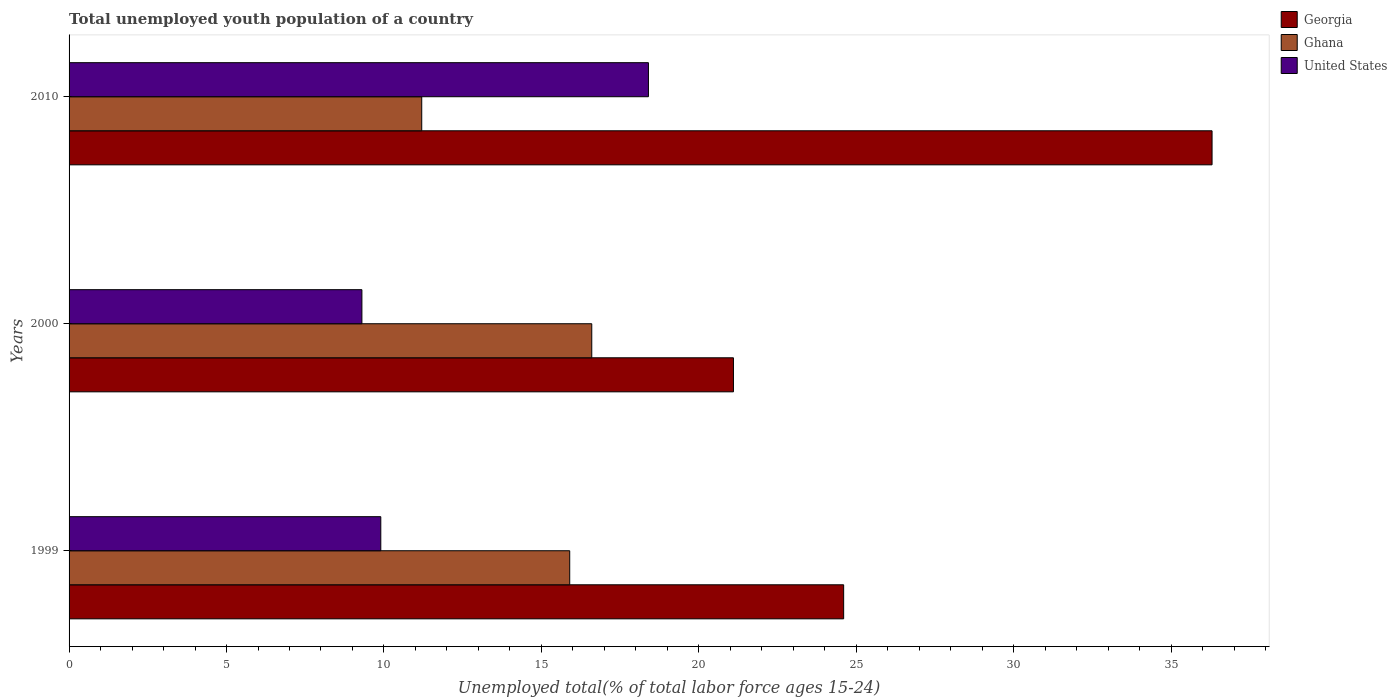How many different coloured bars are there?
Offer a terse response. 3. How many groups of bars are there?
Your answer should be compact. 3. Are the number of bars per tick equal to the number of legend labels?
Offer a terse response. Yes. Are the number of bars on each tick of the Y-axis equal?
Your response must be concise. Yes. How many bars are there on the 1st tick from the top?
Provide a succinct answer. 3. What is the label of the 1st group of bars from the top?
Your answer should be very brief. 2010. What is the percentage of total unemployed youth population of a country in Ghana in 1999?
Ensure brevity in your answer.  15.9. Across all years, what is the maximum percentage of total unemployed youth population of a country in Georgia?
Your response must be concise. 36.3. Across all years, what is the minimum percentage of total unemployed youth population of a country in Ghana?
Provide a succinct answer. 11.2. In which year was the percentage of total unemployed youth population of a country in Georgia maximum?
Offer a terse response. 2010. What is the total percentage of total unemployed youth population of a country in Georgia in the graph?
Provide a short and direct response. 82. What is the difference between the percentage of total unemployed youth population of a country in United States in 1999 and that in 2000?
Your response must be concise. 0.6. What is the difference between the percentage of total unemployed youth population of a country in Ghana in 2010 and the percentage of total unemployed youth population of a country in Georgia in 2000?
Your response must be concise. -9.9. What is the average percentage of total unemployed youth population of a country in Georgia per year?
Provide a short and direct response. 27.33. In the year 2010, what is the difference between the percentage of total unemployed youth population of a country in United States and percentage of total unemployed youth population of a country in Georgia?
Your answer should be very brief. -17.9. In how many years, is the percentage of total unemployed youth population of a country in United States greater than 22 %?
Your answer should be compact. 0. What is the ratio of the percentage of total unemployed youth population of a country in Ghana in 1999 to that in 2000?
Give a very brief answer. 0.96. Is the percentage of total unemployed youth population of a country in Ghana in 2000 less than that in 2010?
Your answer should be very brief. No. What is the difference between the highest and the second highest percentage of total unemployed youth population of a country in United States?
Provide a succinct answer. 8.5. What is the difference between the highest and the lowest percentage of total unemployed youth population of a country in Georgia?
Make the answer very short. 15.2. In how many years, is the percentage of total unemployed youth population of a country in Georgia greater than the average percentage of total unemployed youth population of a country in Georgia taken over all years?
Provide a short and direct response. 1. Is the sum of the percentage of total unemployed youth population of a country in Georgia in 1999 and 2010 greater than the maximum percentage of total unemployed youth population of a country in Ghana across all years?
Offer a terse response. Yes. What does the 1st bar from the bottom in 1999 represents?
Ensure brevity in your answer.  Georgia. Are all the bars in the graph horizontal?
Offer a terse response. Yes. What is the difference between two consecutive major ticks on the X-axis?
Keep it short and to the point. 5. Are the values on the major ticks of X-axis written in scientific E-notation?
Your answer should be very brief. No. Does the graph contain grids?
Provide a short and direct response. No. What is the title of the graph?
Make the answer very short. Total unemployed youth population of a country. What is the label or title of the X-axis?
Your answer should be very brief. Unemployed total(% of total labor force ages 15-24). What is the Unemployed total(% of total labor force ages 15-24) in Georgia in 1999?
Provide a short and direct response. 24.6. What is the Unemployed total(% of total labor force ages 15-24) of Ghana in 1999?
Your response must be concise. 15.9. What is the Unemployed total(% of total labor force ages 15-24) in United States in 1999?
Ensure brevity in your answer.  9.9. What is the Unemployed total(% of total labor force ages 15-24) in Georgia in 2000?
Make the answer very short. 21.1. What is the Unemployed total(% of total labor force ages 15-24) of Ghana in 2000?
Your answer should be compact. 16.6. What is the Unemployed total(% of total labor force ages 15-24) in United States in 2000?
Your answer should be compact. 9.3. What is the Unemployed total(% of total labor force ages 15-24) in Georgia in 2010?
Offer a terse response. 36.3. What is the Unemployed total(% of total labor force ages 15-24) in Ghana in 2010?
Your answer should be compact. 11.2. What is the Unemployed total(% of total labor force ages 15-24) in United States in 2010?
Ensure brevity in your answer.  18.4. Across all years, what is the maximum Unemployed total(% of total labor force ages 15-24) of Georgia?
Offer a terse response. 36.3. Across all years, what is the maximum Unemployed total(% of total labor force ages 15-24) of Ghana?
Your response must be concise. 16.6. Across all years, what is the maximum Unemployed total(% of total labor force ages 15-24) of United States?
Make the answer very short. 18.4. Across all years, what is the minimum Unemployed total(% of total labor force ages 15-24) of Georgia?
Provide a short and direct response. 21.1. Across all years, what is the minimum Unemployed total(% of total labor force ages 15-24) in Ghana?
Keep it short and to the point. 11.2. Across all years, what is the minimum Unemployed total(% of total labor force ages 15-24) of United States?
Your answer should be compact. 9.3. What is the total Unemployed total(% of total labor force ages 15-24) of Ghana in the graph?
Your answer should be very brief. 43.7. What is the total Unemployed total(% of total labor force ages 15-24) in United States in the graph?
Your answer should be compact. 37.6. What is the difference between the Unemployed total(% of total labor force ages 15-24) in Georgia in 1999 and that in 2010?
Provide a succinct answer. -11.7. What is the difference between the Unemployed total(% of total labor force ages 15-24) of Ghana in 1999 and that in 2010?
Offer a very short reply. 4.7. What is the difference between the Unemployed total(% of total labor force ages 15-24) of United States in 1999 and that in 2010?
Provide a short and direct response. -8.5. What is the difference between the Unemployed total(% of total labor force ages 15-24) in Georgia in 2000 and that in 2010?
Keep it short and to the point. -15.2. What is the difference between the Unemployed total(% of total labor force ages 15-24) in Ghana in 2000 and that in 2010?
Make the answer very short. 5.4. What is the difference between the Unemployed total(% of total labor force ages 15-24) of Georgia in 1999 and the Unemployed total(% of total labor force ages 15-24) of Ghana in 2000?
Your answer should be compact. 8. What is the difference between the Unemployed total(% of total labor force ages 15-24) in Georgia in 1999 and the Unemployed total(% of total labor force ages 15-24) in United States in 2000?
Offer a very short reply. 15.3. What is the difference between the Unemployed total(% of total labor force ages 15-24) of Ghana in 1999 and the Unemployed total(% of total labor force ages 15-24) of United States in 2010?
Ensure brevity in your answer.  -2.5. What is the difference between the Unemployed total(% of total labor force ages 15-24) in Ghana in 2000 and the Unemployed total(% of total labor force ages 15-24) in United States in 2010?
Offer a terse response. -1.8. What is the average Unemployed total(% of total labor force ages 15-24) in Georgia per year?
Keep it short and to the point. 27.33. What is the average Unemployed total(% of total labor force ages 15-24) of Ghana per year?
Offer a very short reply. 14.57. What is the average Unemployed total(% of total labor force ages 15-24) in United States per year?
Make the answer very short. 12.53. In the year 1999, what is the difference between the Unemployed total(% of total labor force ages 15-24) in Georgia and Unemployed total(% of total labor force ages 15-24) in United States?
Make the answer very short. 14.7. In the year 2000, what is the difference between the Unemployed total(% of total labor force ages 15-24) of Georgia and Unemployed total(% of total labor force ages 15-24) of Ghana?
Offer a terse response. 4.5. In the year 2010, what is the difference between the Unemployed total(% of total labor force ages 15-24) in Georgia and Unemployed total(% of total labor force ages 15-24) in Ghana?
Provide a succinct answer. 25.1. In the year 2010, what is the difference between the Unemployed total(% of total labor force ages 15-24) of Georgia and Unemployed total(% of total labor force ages 15-24) of United States?
Keep it short and to the point. 17.9. What is the ratio of the Unemployed total(% of total labor force ages 15-24) of Georgia in 1999 to that in 2000?
Provide a short and direct response. 1.17. What is the ratio of the Unemployed total(% of total labor force ages 15-24) of Ghana in 1999 to that in 2000?
Give a very brief answer. 0.96. What is the ratio of the Unemployed total(% of total labor force ages 15-24) in United States in 1999 to that in 2000?
Give a very brief answer. 1.06. What is the ratio of the Unemployed total(% of total labor force ages 15-24) of Georgia in 1999 to that in 2010?
Offer a terse response. 0.68. What is the ratio of the Unemployed total(% of total labor force ages 15-24) of Ghana in 1999 to that in 2010?
Make the answer very short. 1.42. What is the ratio of the Unemployed total(% of total labor force ages 15-24) in United States in 1999 to that in 2010?
Your answer should be very brief. 0.54. What is the ratio of the Unemployed total(% of total labor force ages 15-24) of Georgia in 2000 to that in 2010?
Your answer should be compact. 0.58. What is the ratio of the Unemployed total(% of total labor force ages 15-24) of Ghana in 2000 to that in 2010?
Make the answer very short. 1.48. What is the ratio of the Unemployed total(% of total labor force ages 15-24) of United States in 2000 to that in 2010?
Keep it short and to the point. 0.51. What is the difference between the highest and the second highest Unemployed total(% of total labor force ages 15-24) of United States?
Make the answer very short. 8.5. What is the difference between the highest and the lowest Unemployed total(% of total labor force ages 15-24) in United States?
Offer a very short reply. 9.1. 